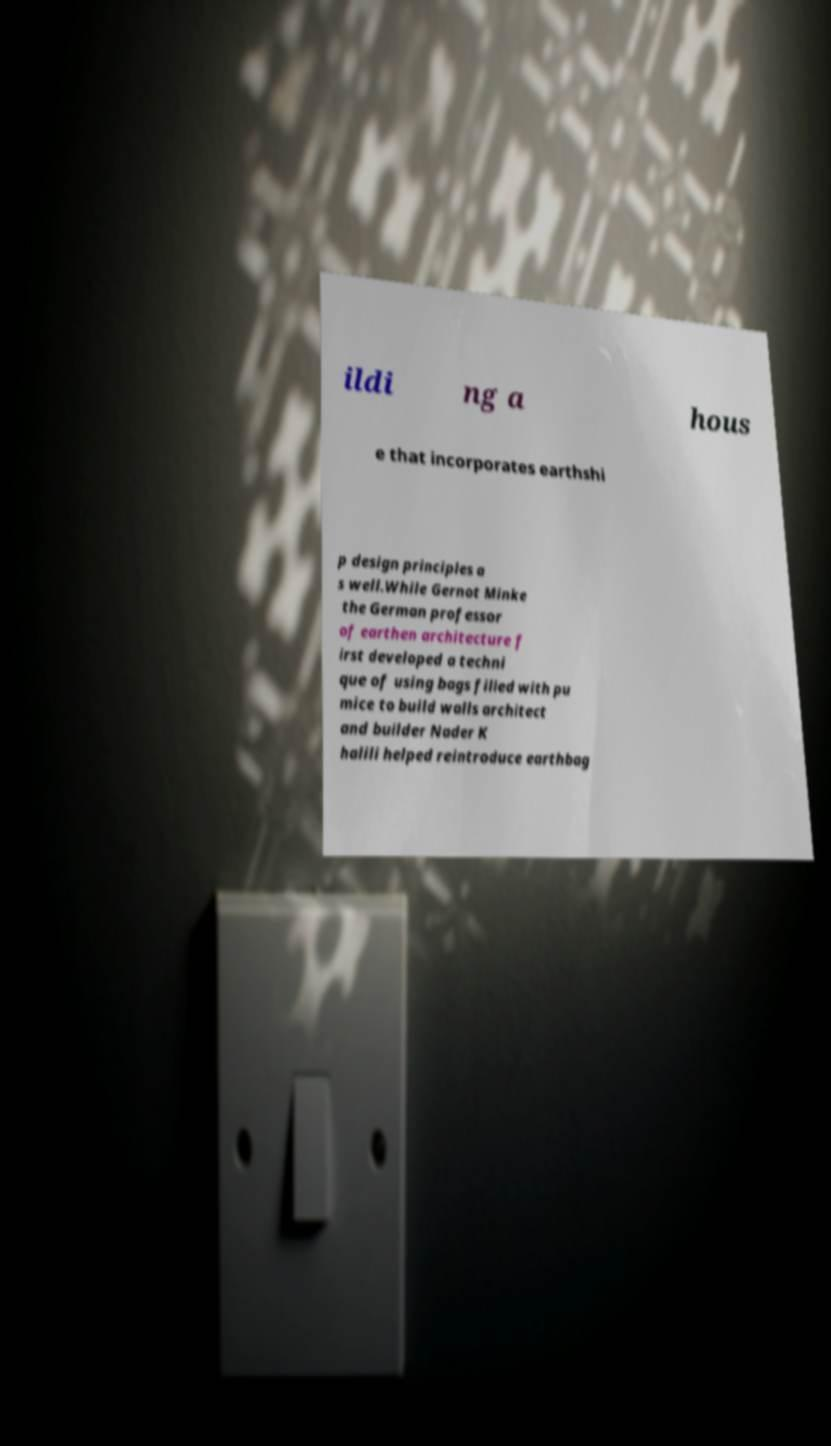I need the written content from this picture converted into text. Can you do that? ildi ng a hous e that incorporates earthshi p design principles a s well.While Gernot Minke the German professor of earthen architecture f irst developed a techni que of using bags filled with pu mice to build walls architect and builder Nader K halili helped reintroduce earthbag 